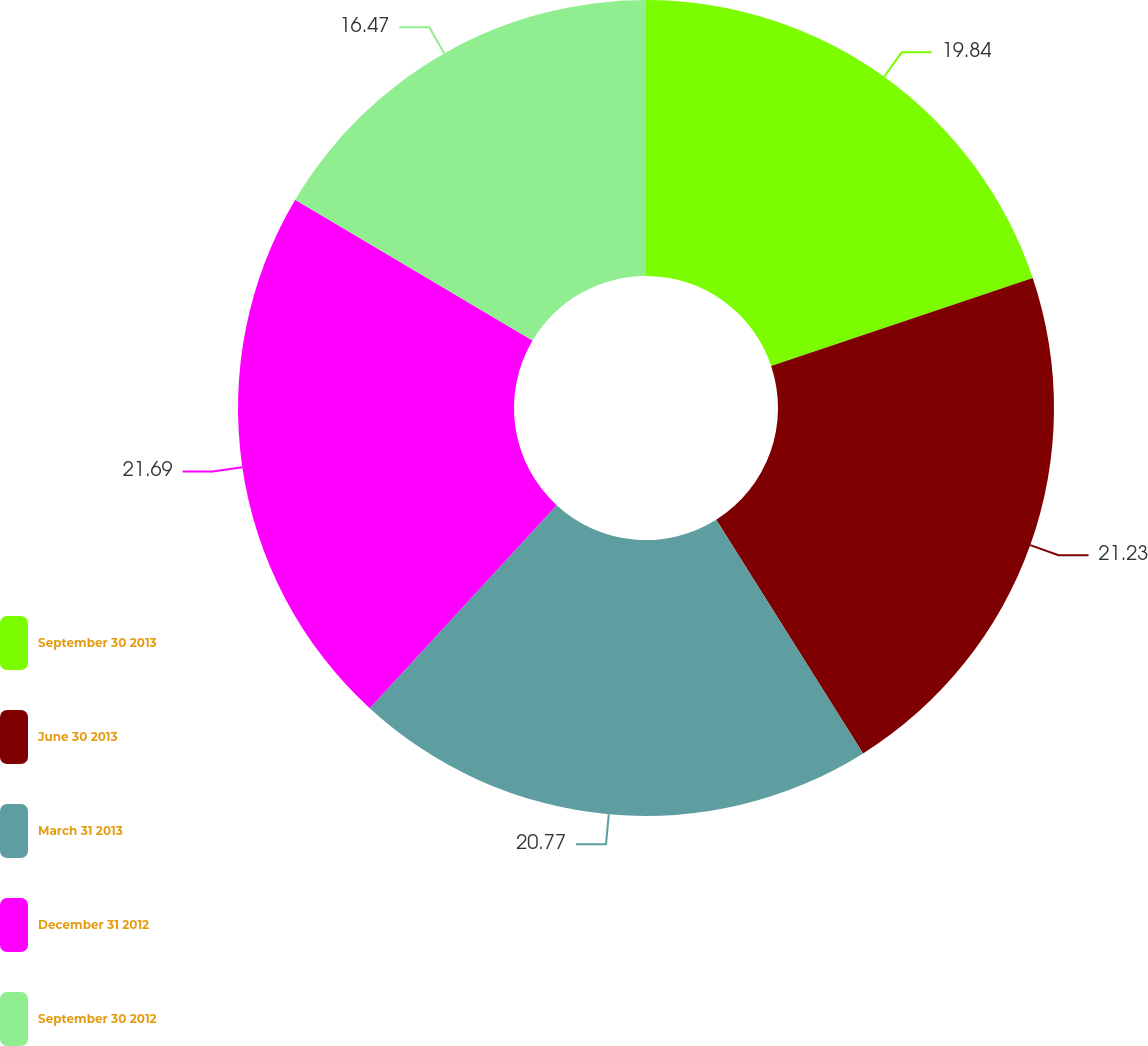Convert chart to OTSL. <chart><loc_0><loc_0><loc_500><loc_500><pie_chart><fcel>September 30 2013<fcel>June 30 2013<fcel>March 31 2013<fcel>December 31 2012<fcel>September 30 2012<nl><fcel>19.84%<fcel>21.23%<fcel>20.77%<fcel>21.69%<fcel>16.47%<nl></chart> 